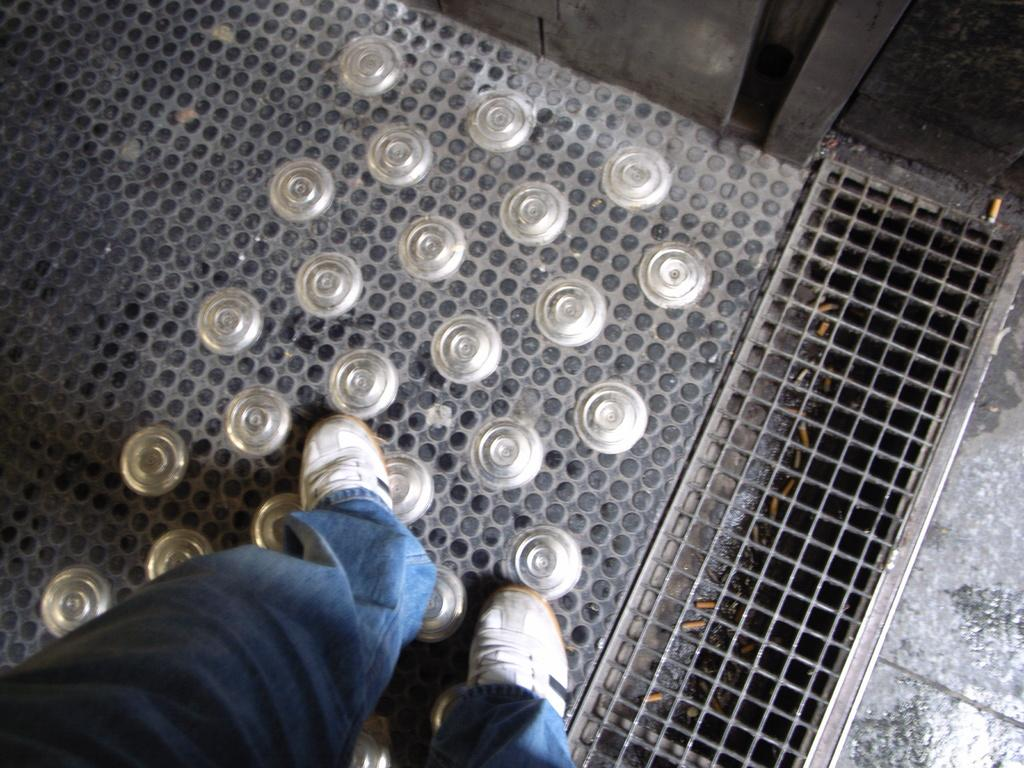What is the primary subject in the image? There is a person standing in the image. Can you describe the surface the person is standing on? The person is standing on an iron floor. What other element can be seen in the image? There is a mesh in the image. What type of print can be seen on the person's shirt in the image? There is no print visible on the person's shirt in the image. Can you see any mountains in the background of the image? There are no mountains present in the image. 